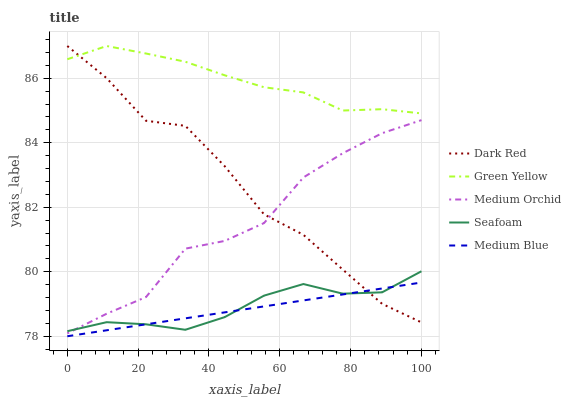Does Medium Blue have the minimum area under the curve?
Answer yes or no. Yes. Does Green Yellow have the maximum area under the curve?
Answer yes or no. Yes. Does Medium Orchid have the minimum area under the curve?
Answer yes or no. No. Does Medium Orchid have the maximum area under the curve?
Answer yes or no. No. Is Medium Blue the smoothest?
Answer yes or no. Yes. Is Dark Red the roughest?
Answer yes or no. Yes. Is Medium Orchid the smoothest?
Answer yes or no. No. Is Medium Orchid the roughest?
Answer yes or no. No. Does Medium Blue have the lowest value?
Answer yes or no. Yes. Does Medium Orchid have the lowest value?
Answer yes or no. No. Does Green Yellow have the highest value?
Answer yes or no. Yes. Does Medium Orchid have the highest value?
Answer yes or no. No. Is Seafoam less than Green Yellow?
Answer yes or no. Yes. Is Medium Orchid greater than Medium Blue?
Answer yes or no. Yes. Does Seafoam intersect Medium Orchid?
Answer yes or no. Yes. Is Seafoam less than Medium Orchid?
Answer yes or no. No. Is Seafoam greater than Medium Orchid?
Answer yes or no. No. Does Seafoam intersect Green Yellow?
Answer yes or no. No. 